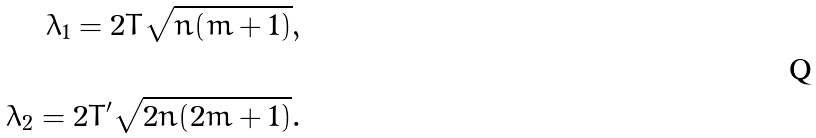Convert formula to latex. <formula><loc_0><loc_0><loc_500><loc_500>\lambda _ { 1 } = 2 T \sqrt { n ( m + 1 ) } , \\ \\ \lambda _ { 2 } = 2 T ^ { \prime } \sqrt { 2 n ( 2 m + 1 ) } .</formula> 